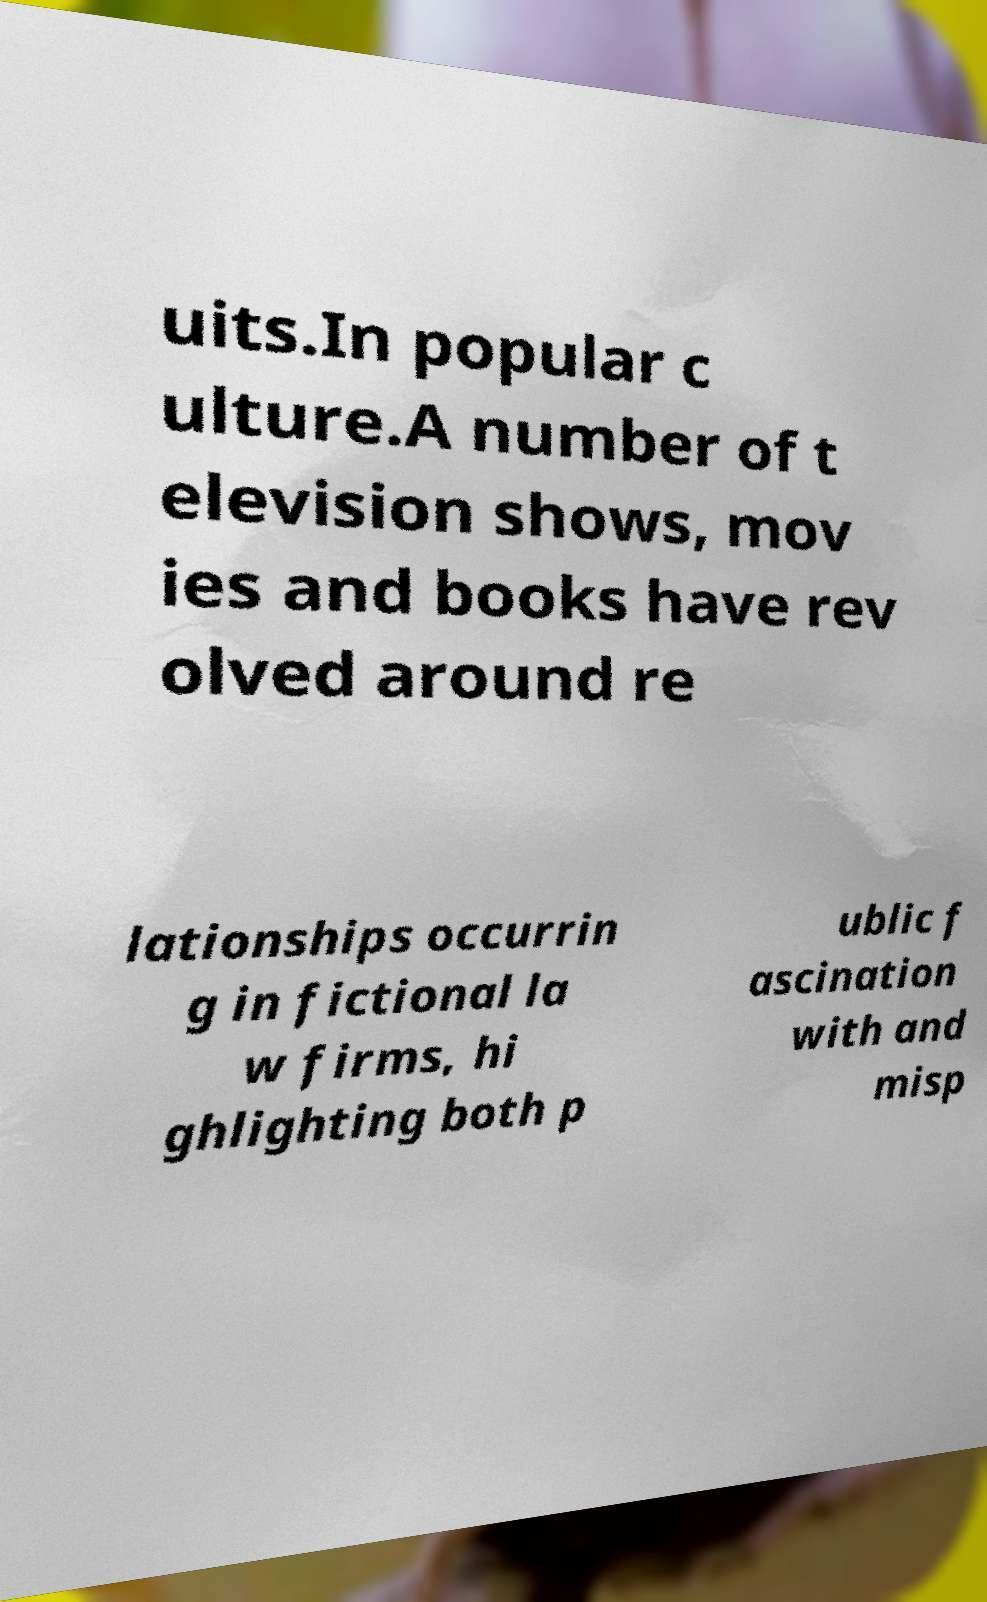For documentation purposes, I need the text within this image transcribed. Could you provide that? uits.In popular c ulture.A number of t elevision shows, mov ies and books have rev olved around re lationships occurrin g in fictional la w firms, hi ghlighting both p ublic f ascination with and misp 